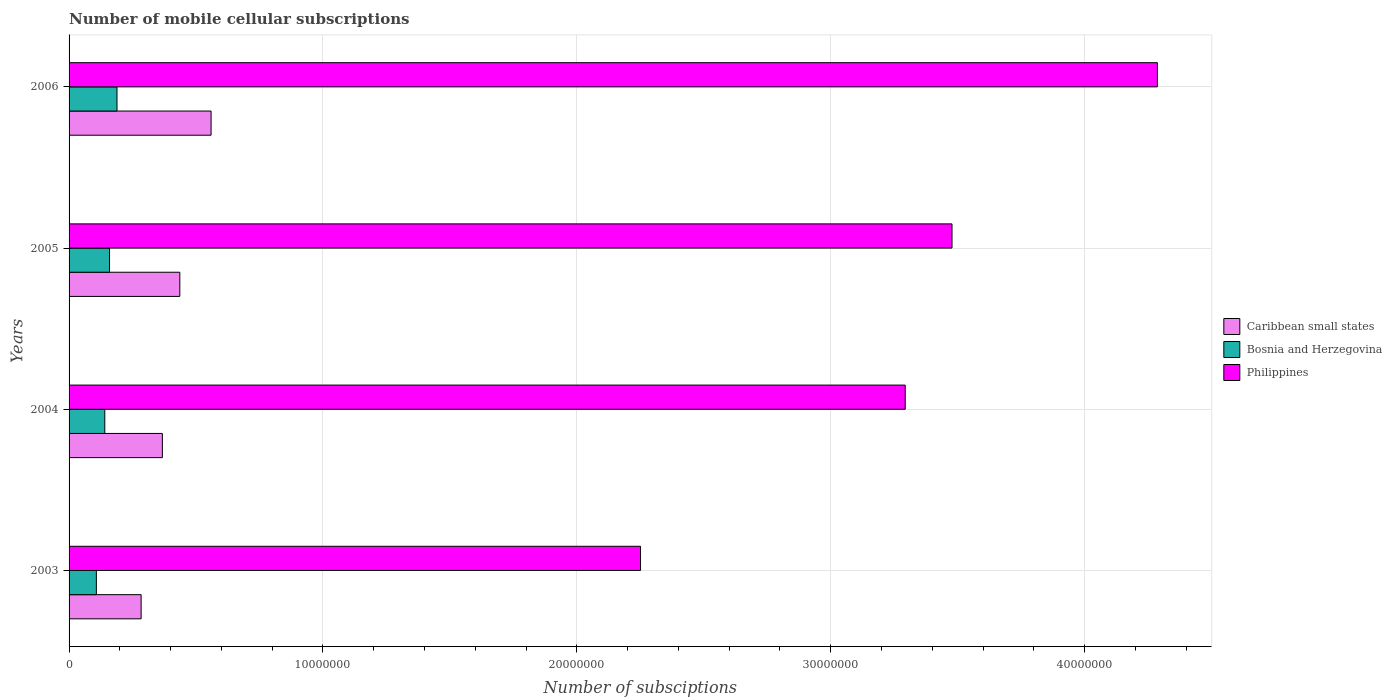How many groups of bars are there?
Offer a terse response. 4. Are the number of bars per tick equal to the number of legend labels?
Provide a short and direct response. Yes. How many bars are there on the 3rd tick from the top?
Offer a very short reply. 3. In how many cases, is the number of bars for a given year not equal to the number of legend labels?
Keep it short and to the point. 0. What is the number of mobile cellular subscriptions in Bosnia and Herzegovina in 2005?
Keep it short and to the point. 1.59e+06. Across all years, what is the maximum number of mobile cellular subscriptions in Caribbean small states?
Your answer should be compact. 5.59e+06. Across all years, what is the minimum number of mobile cellular subscriptions in Bosnia and Herzegovina?
Your answer should be very brief. 1.07e+06. In which year was the number of mobile cellular subscriptions in Caribbean small states maximum?
Your answer should be very brief. 2006. In which year was the number of mobile cellular subscriptions in Philippines minimum?
Provide a short and direct response. 2003. What is the total number of mobile cellular subscriptions in Caribbean small states in the graph?
Provide a short and direct response. 1.65e+07. What is the difference between the number of mobile cellular subscriptions in Philippines in 2005 and that in 2006?
Ensure brevity in your answer.  -8.09e+06. What is the difference between the number of mobile cellular subscriptions in Philippines in 2004 and the number of mobile cellular subscriptions in Caribbean small states in 2006?
Give a very brief answer. 2.73e+07. What is the average number of mobile cellular subscriptions in Caribbean small states per year?
Your response must be concise. 4.12e+06. In the year 2005, what is the difference between the number of mobile cellular subscriptions in Bosnia and Herzegovina and number of mobile cellular subscriptions in Philippines?
Provide a succinct answer. -3.32e+07. What is the ratio of the number of mobile cellular subscriptions in Caribbean small states in 2003 to that in 2004?
Give a very brief answer. 0.77. Is the number of mobile cellular subscriptions in Bosnia and Herzegovina in 2005 less than that in 2006?
Ensure brevity in your answer.  Yes. What is the difference between the highest and the second highest number of mobile cellular subscriptions in Philippines?
Make the answer very short. 8.09e+06. What is the difference between the highest and the lowest number of mobile cellular subscriptions in Bosnia and Herzegovina?
Offer a terse response. 8.13e+05. Is the sum of the number of mobile cellular subscriptions in Philippines in 2004 and 2006 greater than the maximum number of mobile cellular subscriptions in Bosnia and Herzegovina across all years?
Give a very brief answer. Yes. What does the 3rd bar from the top in 2005 represents?
Offer a terse response. Caribbean small states. What does the 2nd bar from the bottom in 2006 represents?
Offer a very short reply. Bosnia and Herzegovina. Is it the case that in every year, the sum of the number of mobile cellular subscriptions in Caribbean small states and number of mobile cellular subscriptions in Bosnia and Herzegovina is greater than the number of mobile cellular subscriptions in Philippines?
Provide a succinct answer. No. How many bars are there?
Provide a short and direct response. 12. How many years are there in the graph?
Provide a short and direct response. 4. Are the values on the major ticks of X-axis written in scientific E-notation?
Offer a terse response. No. Where does the legend appear in the graph?
Give a very brief answer. Center right. How are the legend labels stacked?
Your response must be concise. Vertical. What is the title of the graph?
Offer a very short reply. Number of mobile cellular subscriptions. What is the label or title of the X-axis?
Your answer should be very brief. Number of subsciptions. What is the Number of subsciptions of Caribbean small states in 2003?
Make the answer very short. 2.84e+06. What is the Number of subsciptions in Bosnia and Herzegovina in 2003?
Provide a short and direct response. 1.07e+06. What is the Number of subsciptions in Philippines in 2003?
Give a very brief answer. 2.25e+07. What is the Number of subsciptions of Caribbean small states in 2004?
Provide a succinct answer. 3.68e+06. What is the Number of subsciptions of Bosnia and Herzegovina in 2004?
Ensure brevity in your answer.  1.41e+06. What is the Number of subsciptions in Philippines in 2004?
Offer a terse response. 3.29e+07. What is the Number of subsciptions in Caribbean small states in 2005?
Offer a terse response. 4.36e+06. What is the Number of subsciptions of Bosnia and Herzegovina in 2005?
Provide a short and direct response. 1.59e+06. What is the Number of subsciptions of Philippines in 2005?
Provide a succinct answer. 3.48e+07. What is the Number of subsciptions of Caribbean small states in 2006?
Your answer should be very brief. 5.59e+06. What is the Number of subsciptions of Bosnia and Herzegovina in 2006?
Your response must be concise. 1.89e+06. What is the Number of subsciptions in Philippines in 2006?
Offer a terse response. 4.29e+07. Across all years, what is the maximum Number of subsciptions in Caribbean small states?
Offer a very short reply. 5.59e+06. Across all years, what is the maximum Number of subsciptions of Bosnia and Herzegovina?
Your response must be concise. 1.89e+06. Across all years, what is the maximum Number of subsciptions in Philippines?
Provide a succinct answer. 4.29e+07. Across all years, what is the minimum Number of subsciptions of Caribbean small states?
Your answer should be compact. 2.84e+06. Across all years, what is the minimum Number of subsciptions of Bosnia and Herzegovina?
Provide a short and direct response. 1.07e+06. Across all years, what is the minimum Number of subsciptions in Philippines?
Offer a very short reply. 2.25e+07. What is the total Number of subsciptions in Caribbean small states in the graph?
Your response must be concise. 1.65e+07. What is the total Number of subsciptions in Bosnia and Herzegovina in the graph?
Ensure brevity in your answer.  5.96e+06. What is the total Number of subsciptions of Philippines in the graph?
Your answer should be compact. 1.33e+08. What is the difference between the Number of subsciptions in Caribbean small states in 2003 and that in 2004?
Ensure brevity in your answer.  -8.38e+05. What is the difference between the Number of subsciptions in Bosnia and Herzegovina in 2003 and that in 2004?
Keep it short and to the point. -3.33e+05. What is the difference between the Number of subsciptions of Philippines in 2003 and that in 2004?
Make the answer very short. -1.04e+07. What is the difference between the Number of subsciptions of Caribbean small states in 2003 and that in 2005?
Provide a succinct answer. -1.52e+06. What is the difference between the Number of subsciptions in Bosnia and Herzegovina in 2003 and that in 2005?
Offer a terse response. -5.20e+05. What is the difference between the Number of subsciptions in Philippines in 2003 and that in 2005?
Provide a succinct answer. -1.23e+07. What is the difference between the Number of subsciptions of Caribbean small states in 2003 and that in 2006?
Keep it short and to the point. -2.76e+06. What is the difference between the Number of subsciptions in Bosnia and Herzegovina in 2003 and that in 2006?
Offer a terse response. -8.13e+05. What is the difference between the Number of subsciptions of Philippines in 2003 and that in 2006?
Your response must be concise. -2.04e+07. What is the difference between the Number of subsciptions of Caribbean small states in 2004 and that in 2005?
Ensure brevity in your answer.  -6.86e+05. What is the difference between the Number of subsciptions in Bosnia and Herzegovina in 2004 and that in 2005?
Provide a short and direct response. -1.87e+05. What is the difference between the Number of subsciptions in Philippines in 2004 and that in 2005?
Offer a very short reply. -1.84e+06. What is the difference between the Number of subsciptions of Caribbean small states in 2004 and that in 2006?
Make the answer very short. -1.92e+06. What is the difference between the Number of subsciptions of Bosnia and Herzegovina in 2004 and that in 2006?
Your response must be concise. -4.80e+05. What is the difference between the Number of subsciptions in Philippines in 2004 and that in 2006?
Provide a succinct answer. -9.93e+06. What is the difference between the Number of subsciptions in Caribbean small states in 2005 and that in 2006?
Make the answer very short. -1.23e+06. What is the difference between the Number of subsciptions in Bosnia and Herzegovina in 2005 and that in 2006?
Keep it short and to the point. -2.93e+05. What is the difference between the Number of subsciptions of Philippines in 2005 and that in 2006?
Your response must be concise. -8.09e+06. What is the difference between the Number of subsciptions of Caribbean small states in 2003 and the Number of subsciptions of Bosnia and Herzegovina in 2004?
Keep it short and to the point. 1.43e+06. What is the difference between the Number of subsciptions in Caribbean small states in 2003 and the Number of subsciptions in Philippines in 2004?
Your answer should be compact. -3.01e+07. What is the difference between the Number of subsciptions in Bosnia and Herzegovina in 2003 and the Number of subsciptions in Philippines in 2004?
Keep it short and to the point. -3.19e+07. What is the difference between the Number of subsciptions in Caribbean small states in 2003 and the Number of subsciptions in Bosnia and Herzegovina in 2005?
Make the answer very short. 1.24e+06. What is the difference between the Number of subsciptions of Caribbean small states in 2003 and the Number of subsciptions of Philippines in 2005?
Your answer should be compact. -3.19e+07. What is the difference between the Number of subsciptions of Bosnia and Herzegovina in 2003 and the Number of subsciptions of Philippines in 2005?
Your response must be concise. -3.37e+07. What is the difference between the Number of subsciptions in Caribbean small states in 2003 and the Number of subsciptions in Bosnia and Herzegovina in 2006?
Give a very brief answer. 9.50e+05. What is the difference between the Number of subsciptions in Caribbean small states in 2003 and the Number of subsciptions in Philippines in 2006?
Your answer should be very brief. -4.00e+07. What is the difference between the Number of subsciptions of Bosnia and Herzegovina in 2003 and the Number of subsciptions of Philippines in 2006?
Provide a short and direct response. -4.18e+07. What is the difference between the Number of subsciptions of Caribbean small states in 2004 and the Number of subsciptions of Bosnia and Herzegovina in 2005?
Your answer should be compact. 2.08e+06. What is the difference between the Number of subsciptions in Caribbean small states in 2004 and the Number of subsciptions in Philippines in 2005?
Keep it short and to the point. -3.11e+07. What is the difference between the Number of subsciptions in Bosnia and Herzegovina in 2004 and the Number of subsciptions in Philippines in 2005?
Your response must be concise. -3.34e+07. What is the difference between the Number of subsciptions in Caribbean small states in 2004 and the Number of subsciptions in Bosnia and Herzegovina in 2006?
Give a very brief answer. 1.79e+06. What is the difference between the Number of subsciptions of Caribbean small states in 2004 and the Number of subsciptions of Philippines in 2006?
Provide a short and direct response. -3.92e+07. What is the difference between the Number of subsciptions of Bosnia and Herzegovina in 2004 and the Number of subsciptions of Philippines in 2006?
Provide a succinct answer. -4.15e+07. What is the difference between the Number of subsciptions of Caribbean small states in 2005 and the Number of subsciptions of Bosnia and Herzegovina in 2006?
Your response must be concise. 2.47e+06. What is the difference between the Number of subsciptions in Caribbean small states in 2005 and the Number of subsciptions in Philippines in 2006?
Offer a terse response. -3.85e+07. What is the difference between the Number of subsciptions of Bosnia and Herzegovina in 2005 and the Number of subsciptions of Philippines in 2006?
Your answer should be compact. -4.13e+07. What is the average Number of subsciptions of Caribbean small states per year?
Keep it short and to the point. 4.12e+06. What is the average Number of subsciptions in Bosnia and Herzegovina per year?
Your answer should be very brief. 1.49e+06. What is the average Number of subsciptions in Philippines per year?
Offer a very short reply. 3.33e+07. In the year 2003, what is the difference between the Number of subsciptions of Caribbean small states and Number of subsciptions of Bosnia and Herzegovina?
Offer a terse response. 1.76e+06. In the year 2003, what is the difference between the Number of subsciptions in Caribbean small states and Number of subsciptions in Philippines?
Offer a terse response. -1.97e+07. In the year 2003, what is the difference between the Number of subsciptions of Bosnia and Herzegovina and Number of subsciptions of Philippines?
Provide a short and direct response. -2.14e+07. In the year 2004, what is the difference between the Number of subsciptions in Caribbean small states and Number of subsciptions in Bosnia and Herzegovina?
Give a very brief answer. 2.27e+06. In the year 2004, what is the difference between the Number of subsciptions in Caribbean small states and Number of subsciptions in Philippines?
Your answer should be very brief. -2.93e+07. In the year 2004, what is the difference between the Number of subsciptions of Bosnia and Herzegovina and Number of subsciptions of Philippines?
Ensure brevity in your answer.  -3.15e+07. In the year 2005, what is the difference between the Number of subsciptions in Caribbean small states and Number of subsciptions in Bosnia and Herzegovina?
Ensure brevity in your answer.  2.77e+06. In the year 2005, what is the difference between the Number of subsciptions in Caribbean small states and Number of subsciptions in Philippines?
Provide a short and direct response. -3.04e+07. In the year 2005, what is the difference between the Number of subsciptions of Bosnia and Herzegovina and Number of subsciptions of Philippines?
Your response must be concise. -3.32e+07. In the year 2006, what is the difference between the Number of subsciptions in Caribbean small states and Number of subsciptions in Bosnia and Herzegovina?
Ensure brevity in your answer.  3.71e+06. In the year 2006, what is the difference between the Number of subsciptions in Caribbean small states and Number of subsciptions in Philippines?
Give a very brief answer. -3.73e+07. In the year 2006, what is the difference between the Number of subsciptions of Bosnia and Herzegovina and Number of subsciptions of Philippines?
Give a very brief answer. -4.10e+07. What is the ratio of the Number of subsciptions of Caribbean small states in 2003 to that in 2004?
Provide a short and direct response. 0.77. What is the ratio of the Number of subsciptions of Bosnia and Herzegovina in 2003 to that in 2004?
Offer a very short reply. 0.76. What is the ratio of the Number of subsciptions of Philippines in 2003 to that in 2004?
Offer a terse response. 0.68. What is the ratio of the Number of subsciptions of Caribbean small states in 2003 to that in 2005?
Your response must be concise. 0.65. What is the ratio of the Number of subsciptions of Bosnia and Herzegovina in 2003 to that in 2005?
Your response must be concise. 0.67. What is the ratio of the Number of subsciptions in Philippines in 2003 to that in 2005?
Give a very brief answer. 0.65. What is the ratio of the Number of subsciptions of Caribbean small states in 2003 to that in 2006?
Your response must be concise. 0.51. What is the ratio of the Number of subsciptions of Bosnia and Herzegovina in 2003 to that in 2006?
Ensure brevity in your answer.  0.57. What is the ratio of the Number of subsciptions of Philippines in 2003 to that in 2006?
Make the answer very short. 0.53. What is the ratio of the Number of subsciptions in Caribbean small states in 2004 to that in 2005?
Offer a terse response. 0.84. What is the ratio of the Number of subsciptions of Bosnia and Herzegovina in 2004 to that in 2005?
Provide a short and direct response. 0.88. What is the ratio of the Number of subsciptions of Philippines in 2004 to that in 2005?
Your answer should be compact. 0.95. What is the ratio of the Number of subsciptions of Caribbean small states in 2004 to that in 2006?
Offer a terse response. 0.66. What is the ratio of the Number of subsciptions in Bosnia and Herzegovina in 2004 to that in 2006?
Keep it short and to the point. 0.75. What is the ratio of the Number of subsciptions of Philippines in 2004 to that in 2006?
Your answer should be very brief. 0.77. What is the ratio of the Number of subsciptions of Caribbean small states in 2005 to that in 2006?
Offer a very short reply. 0.78. What is the ratio of the Number of subsciptions in Bosnia and Herzegovina in 2005 to that in 2006?
Your response must be concise. 0.84. What is the ratio of the Number of subsciptions of Philippines in 2005 to that in 2006?
Make the answer very short. 0.81. What is the difference between the highest and the second highest Number of subsciptions of Caribbean small states?
Offer a very short reply. 1.23e+06. What is the difference between the highest and the second highest Number of subsciptions in Bosnia and Herzegovina?
Offer a terse response. 2.93e+05. What is the difference between the highest and the second highest Number of subsciptions of Philippines?
Offer a very short reply. 8.09e+06. What is the difference between the highest and the lowest Number of subsciptions in Caribbean small states?
Offer a very short reply. 2.76e+06. What is the difference between the highest and the lowest Number of subsciptions of Bosnia and Herzegovina?
Your answer should be very brief. 8.13e+05. What is the difference between the highest and the lowest Number of subsciptions in Philippines?
Ensure brevity in your answer.  2.04e+07. 